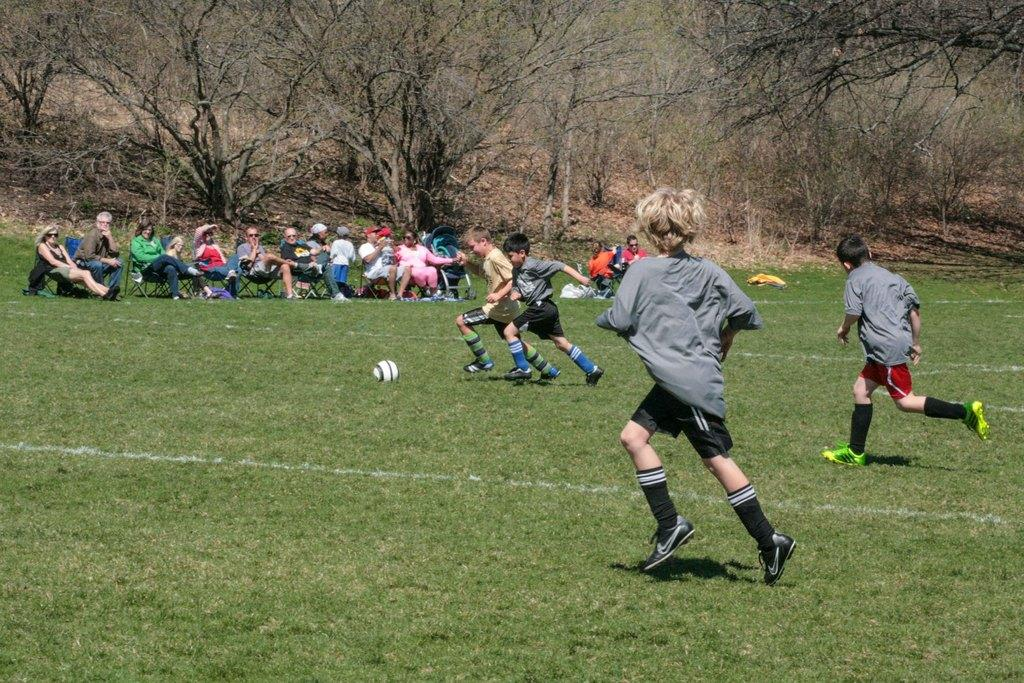What are the kids doing in the image? The kids are running in the image. What are the people doing who are not running? There are people sitting on chairs in the image. What object is on the grass in the image? There is a ball on the grass in the image. What type of transportation is present for a baby or young child in the image? There is a stroller in the image. What can be seen in the distance in the image? Trees are visible in the background of the image. Can you tell me how many cans are being shaken by the kids in the image? There are no cans present in the image; the kids are running and there are no cans mentioned in the facts. What is the desire of the people sitting on chairs in the image? There is no information about the desires of the people sitting on chairs in the image, as the facts only mention their position and not their thoughts or intentions. 